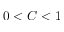Convert formula to latex. <formula><loc_0><loc_0><loc_500><loc_500>0 < C < 1</formula> 